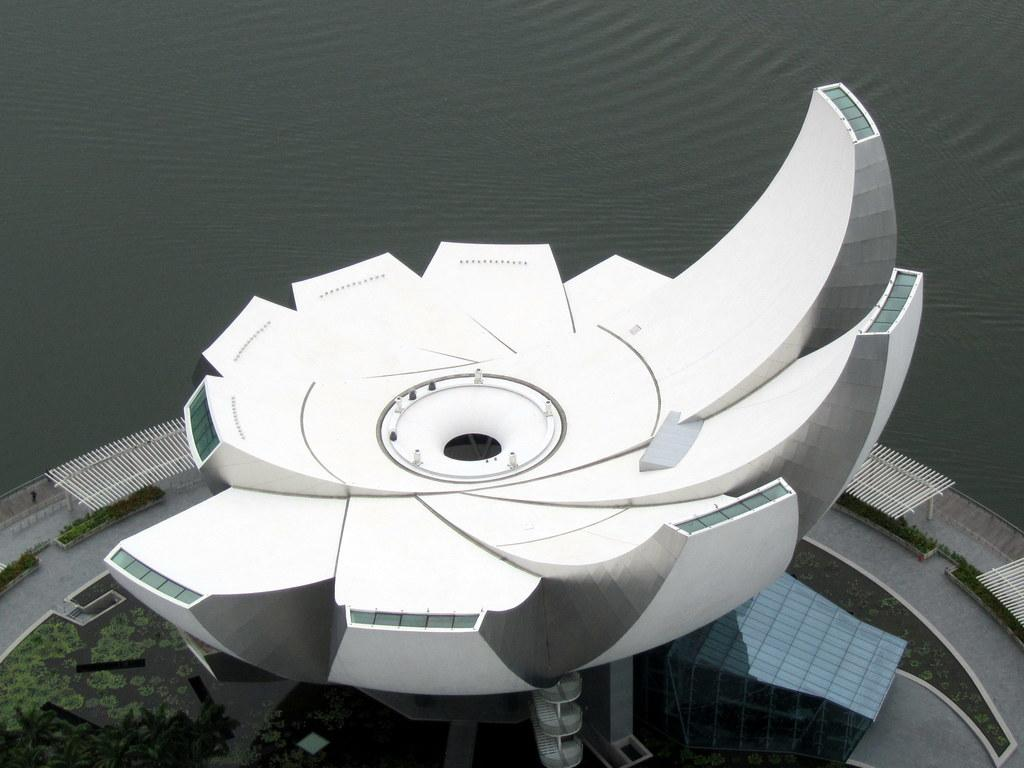What type of structure is present in the image? There is a building in the image. What feature surrounds the building? There is a railing around the building. What natural element is visible in the image? There is water visible in the image. What type of vegetation is at the bottom of the image? There is grass at the bottom of the image. What type of toy can be seen floating in the water in the image? There is no toy visible in the water in the image. How many nails are used to hold the railing in place in the image? The image does not provide information about the construction of the railing, so we cannot determine the number of nails used. 